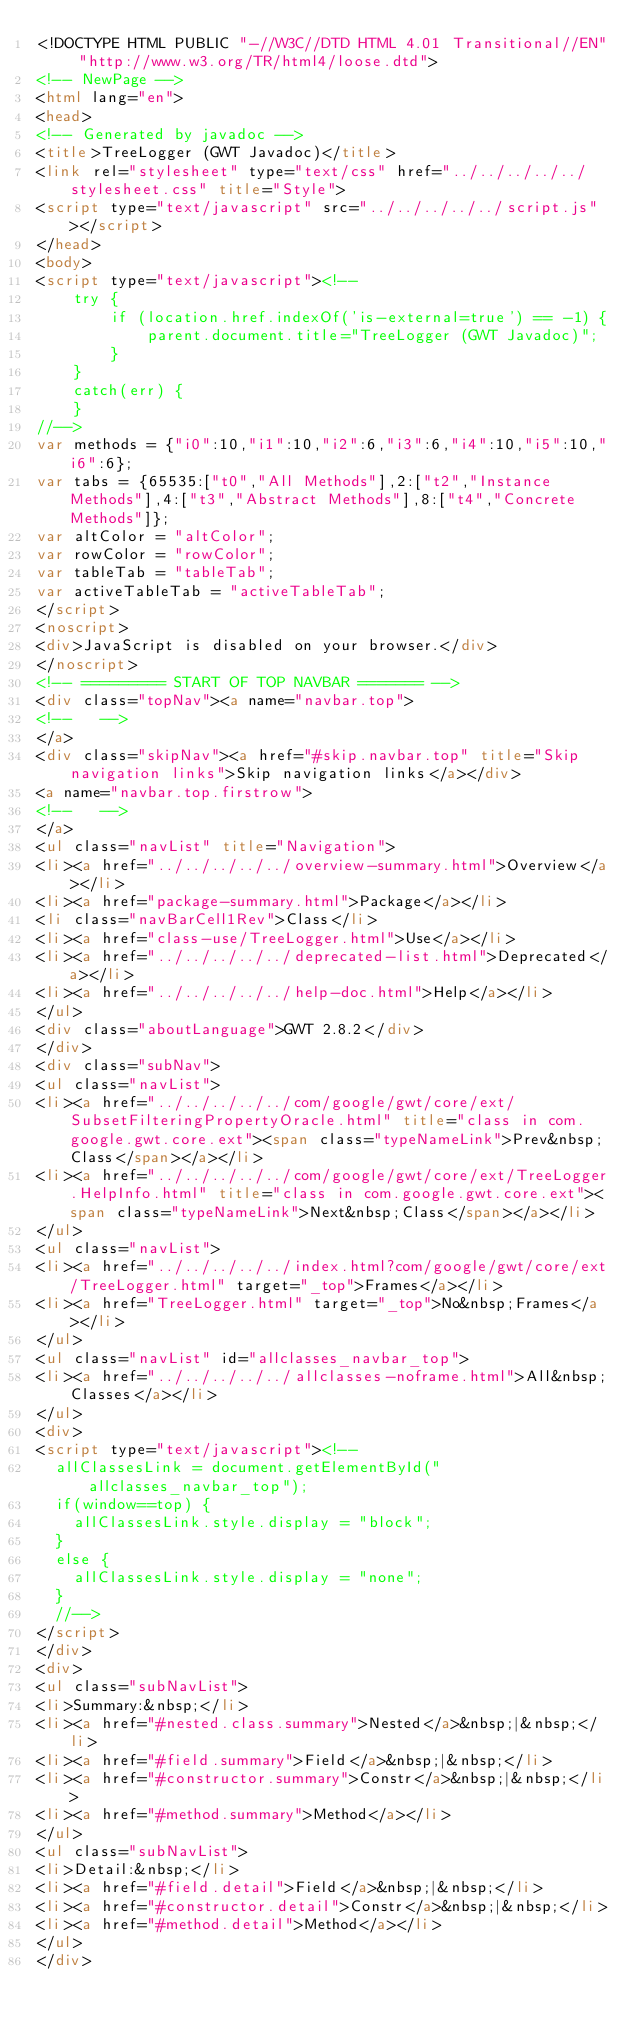<code> <loc_0><loc_0><loc_500><loc_500><_HTML_><!DOCTYPE HTML PUBLIC "-//W3C//DTD HTML 4.01 Transitional//EN" "http://www.w3.org/TR/html4/loose.dtd">
<!-- NewPage -->
<html lang="en">
<head>
<!-- Generated by javadoc -->
<title>TreeLogger (GWT Javadoc)</title>
<link rel="stylesheet" type="text/css" href="../../../../../stylesheet.css" title="Style">
<script type="text/javascript" src="../../../../../script.js"></script>
</head>
<body>
<script type="text/javascript"><!--
    try {
        if (location.href.indexOf('is-external=true') == -1) {
            parent.document.title="TreeLogger (GWT Javadoc)";
        }
    }
    catch(err) {
    }
//-->
var methods = {"i0":10,"i1":10,"i2":6,"i3":6,"i4":10,"i5":10,"i6":6};
var tabs = {65535:["t0","All Methods"],2:["t2","Instance Methods"],4:["t3","Abstract Methods"],8:["t4","Concrete Methods"]};
var altColor = "altColor";
var rowColor = "rowColor";
var tableTab = "tableTab";
var activeTableTab = "activeTableTab";
</script>
<noscript>
<div>JavaScript is disabled on your browser.</div>
</noscript>
<!-- ========= START OF TOP NAVBAR ======= -->
<div class="topNav"><a name="navbar.top">
<!--   -->
</a>
<div class="skipNav"><a href="#skip.navbar.top" title="Skip navigation links">Skip navigation links</a></div>
<a name="navbar.top.firstrow">
<!--   -->
</a>
<ul class="navList" title="Navigation">
<li><a href="../../../../../overview-summary.html">Overview</a></li>
<li><a href="package-summary.html">Package</a></li>
<li class="navBarCell1Rev">Class</li>
<li><a href="class-use/TreeLogger.html">Use</a></li>
<li><a href="../../../../../deprecated-list.html">Deprecated</a></li>
<li><a href="../../../../../help-doc.html">Help</a></li>
</ul>
<div class="aboutLanguage">GWT 2.8.2</div>
</div>
<div class="subNav">
<ul class="navList">
<li><a href="../../../../../com/google/gwt/core/ext/SubsetFilteringPropertyOracle.html" title="class in com.google.gwt.core.ext"><span class="typeNameLink">Prev&nbsp;Class</span></a></li>
<li><a href="../../../../../com/google/gwt/core/ext/TreeLogger.HelpInfo.html" title="class in com.google.gwt.core.ext"><span class="typeNameLink">Next&nbsp;Class</span></a></li>
</ul>
<ul class="navList">
<li><a href="../../../../../index.html?com/google/gwt/core/ext/TreeLogger.html" target="_top">Frames</a></li>
<li><a href="TreeLogger.html" target="_top">No&nbsp;Frames</a></li>
</ul>
<ul class="navList" id="allclasses_navbar_top">
<li><a href="../../../../../allclasses-noframe.html">All&nbsp;Classes</a></li>
</ul>
<div>
<script type="text/javascript"><!--
  allClassesLink = document.getElementById("allclasses_navbar_top");
  if(window==top) {
    allClassesLink.style.display = "block";
  }
  else {
    allClassesLink.style.display = "none";
  }
  //-->
</script>
</div>
<div>
<ul class="subNavList">
<li>Summary:&nbsp;</li>
<li><a href="#nested.class.summary">Nested</a>&nbsp;|&nbsp;</li>
<li><a href="#field.summary">Field</a>&nbsp;|&nbsp;</li>
<li><a href="#constructor.summary">Constr</a>&nbsp;|&nbsp;</li>
<li><a href="#method.summary">Method</a></li>
</ul>
<ul class="subNavList">
<li>Detail:&nbsp;</li>
<li><a href="#field.detail">Field</a>&nbsp;|&nbsp;</li>
<li><a href="#constructor.detail">Constr</a>&nbsp;|&nbsp;</li>
<li><a href="#method.detail">Method</a></li>
</ul>
</div></code> 